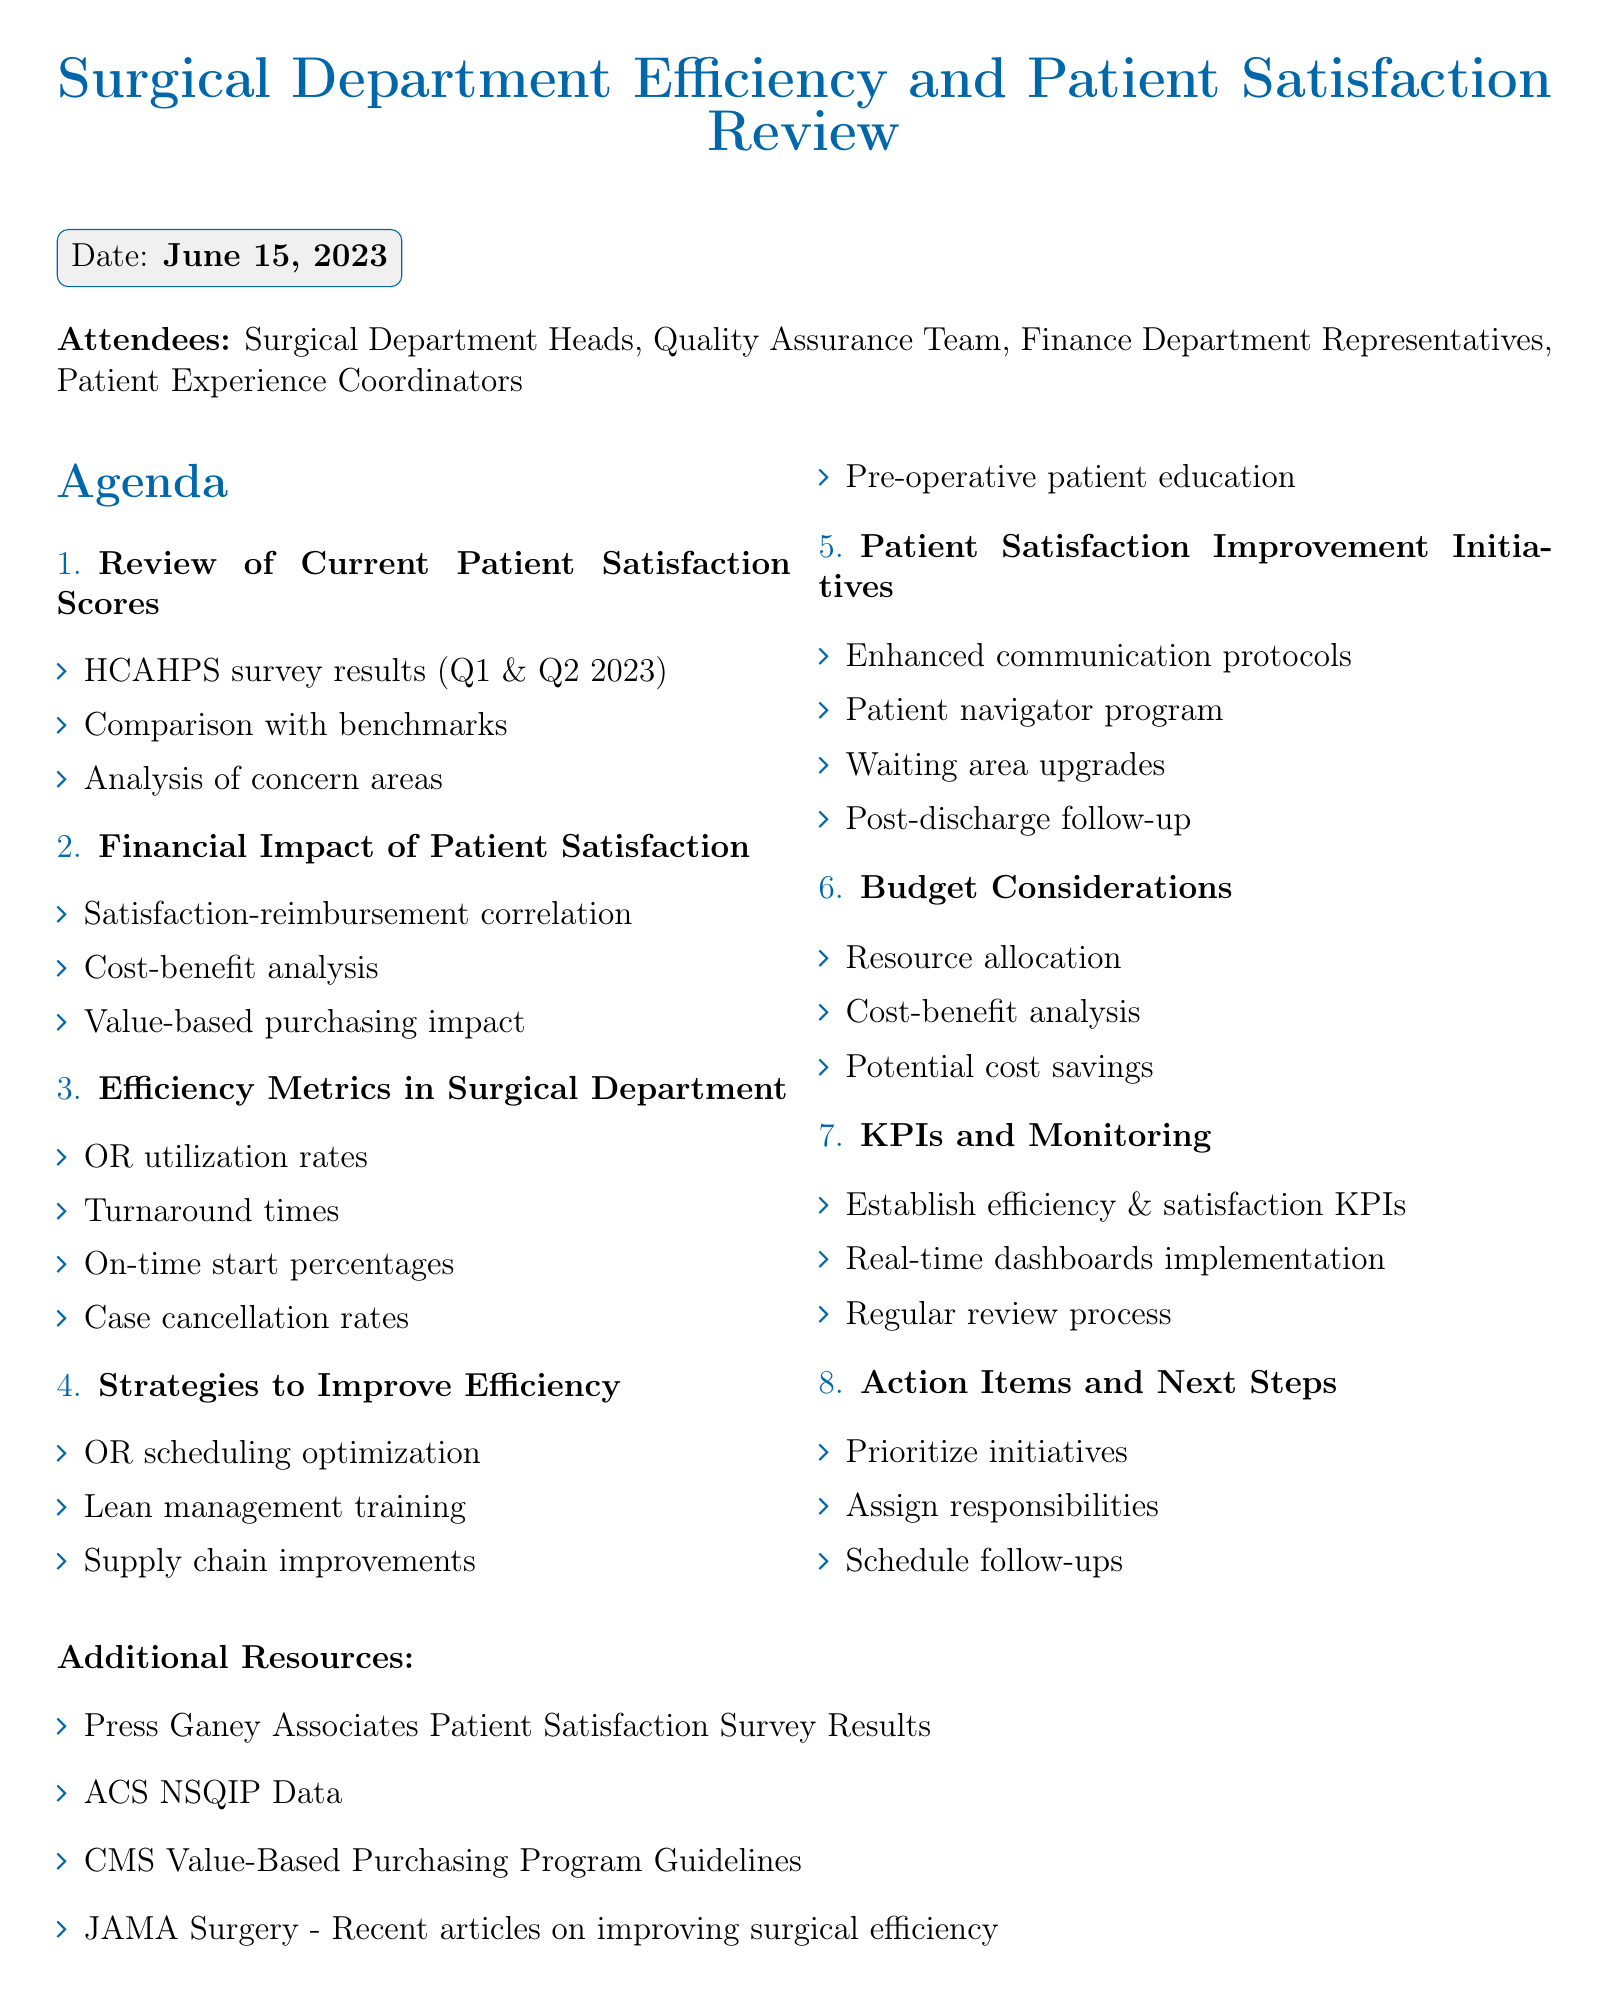what is the meeting date? The meeting date is specified in the document under the "meeting_date" section.
Answer: June 15, 2023 who presented the patient satisfaction scores? This corresponds to the attendees in the document, specifically those involved in presentations.
Answer: Surgical Department Heads what are the efficiency metrics discussed? The document lists several efficiency metrics which can be found under the relevant agenda item.
Answer: Operating room utilization rates, Average turnaround times, On-time start percentages, Case cancellation rates which software is mentioned for OR scheduling optimization? The document explicitly refers to a specific software in the agenda item discussing improvement strategies.
Answer: Surgical Information Systems what is the purpose of the patient navigator program? This initiative is mentioned under patient satisfaction improvement initiatives and intended to enhance patient care.
Answer: For complex cases how many areas of concern are primarily analyzed in the patient satisfaction scores? The document outlines specific areas of concern when reviewing the satisfaction scores.
Answer: Three what are the additional resources listed? Additional resources are provided at the end of the document as sources for further information.
Answer: Press Ganey Associates Patient Satisfaction Survey Results, ACS NSQIP Data, CMS Value-Based Purchasing Program Guidelines, JAMA Surgery - Recent articles on improving surgical efficiency what action items are specified in the agenda? The action items are presented in a dedicated section that outlines next steps for the meeting attendees.
Answer: Prioritization of improvement initiatives, Assignment of responsibilities, Schedule for follow-up meetings and progress reports 